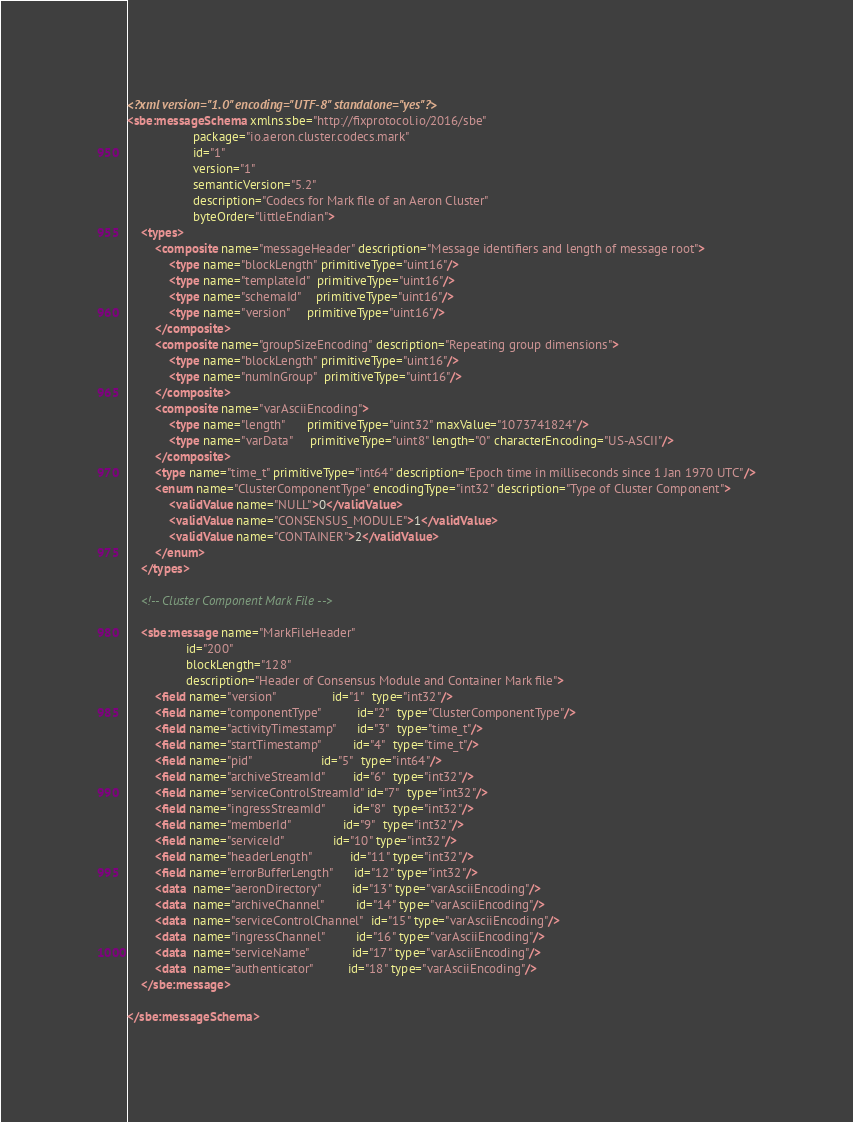Convert code to text. <code><loc_0><loc_0><loc_500><loc_500><_XML_><?xml version="1.0" encoding="UTF-8" standalone="yes"?>
<sbe:messageSchema xmlns:sbe="http://fixprotocol.io/2016/sbe"
                   package="io.aeron.cluster.codecs.mark"
                   id="1"
                   version="1"
                   semanticVersion="5.2"
                   description="Codecs for Mark file of an Aeron Cluster"
                   byteOrder="littleEndian">
    <types>
        <composite name="messageHeader" description="Message identifiers and length of message root">
            <type name="blockLength" primitiveType="uint16"/>
            <type name="templateId"  primitiveType="uint16"/>
            <type name="schemaId"    primitiveType="uint16"/>
            <type name="version"     primitiveType="uint16"/>
        </composite>
        <composite name="groupSizeEncoding" description="Repeating group dimensions">
            <type name="blockLength" primitiveType="uint16"/>
            <type name="numInGroup"  primitiveType="uint16"/>
        </composite>
        <composite name="varAsciiEncoding">
            <type name="length"      primitiveType="uint32" maxValue="1073741824"/>
            <type name="varData"     primitiveType="uint8" length="0" characterEncoding="US-ASCII"/>
        </composite>
        <type name="time_t" primitiveType="int64" description="Epoch time in milliseconds since 1 Jan 1970 UTC"/>
        <enum name="ClusterComponentType" encodingType="int32" description="Type of Cluster Component">
            <validValue name="NULL">0</validValue>
            <validValue name="CONSENSUS_MODULE">1</validValue>
            <validValue name="CONTAINER">2</validValue>
        </enum>
    </types>

    <!-- Cluster Component Mark File -->

    <sbe:message name="MarkFileHeader"
                 id="200"
                 blockLength="128"
                 description="Header of Consensus Module and Container Mark file">
        <field name="version"                id="1"  type="int32"/>
        <field name="componentType"          id="2"  type="ClusterComponentType"/>
        <field name="activityTimestamp"      id="3"  type="time_t"/>
        <field name="startTimestamp"         id="4"  type="time_t"/>
        <field name="pid"                    id="5"  type="int64"/>
        <field name="archiveStreamId"        id="6"  type="int32"/>
        <field name="serviceControlStreamId" id="7"  type="int32"/>
        <field name="ingressStreamId"        id="8"  type="int32"/>
        <field name="memberId"               id="9"  type="int32"/>
        <field name="serviceId"              id="10" type="int32"/>
        <field name="headerLength"           id="11" type="int32"/>
        <field name="errorBufferLength"      id="12" type="int32"/>
        <data  name="aeronDirectory"         id="13" type="varAsciiEncoding"/>
        <data  name="archiveChannel"         id="14" type="varAsciiEncoding"/>
        <data  name="serviceControlChannel"  id="15" type="varAsciiEncoding"/>
        <data  name="ingressChannel"         id="16" type="varAsciiEncoding"/>
        <data  name="serviceName"            id="17" type="varAsciiEncoding"/>
        <data  name="authenticator"          id="18" type="varAsciiEncoding"/>
    </sbe:message>

</sbe:messageSchema>
</code> 